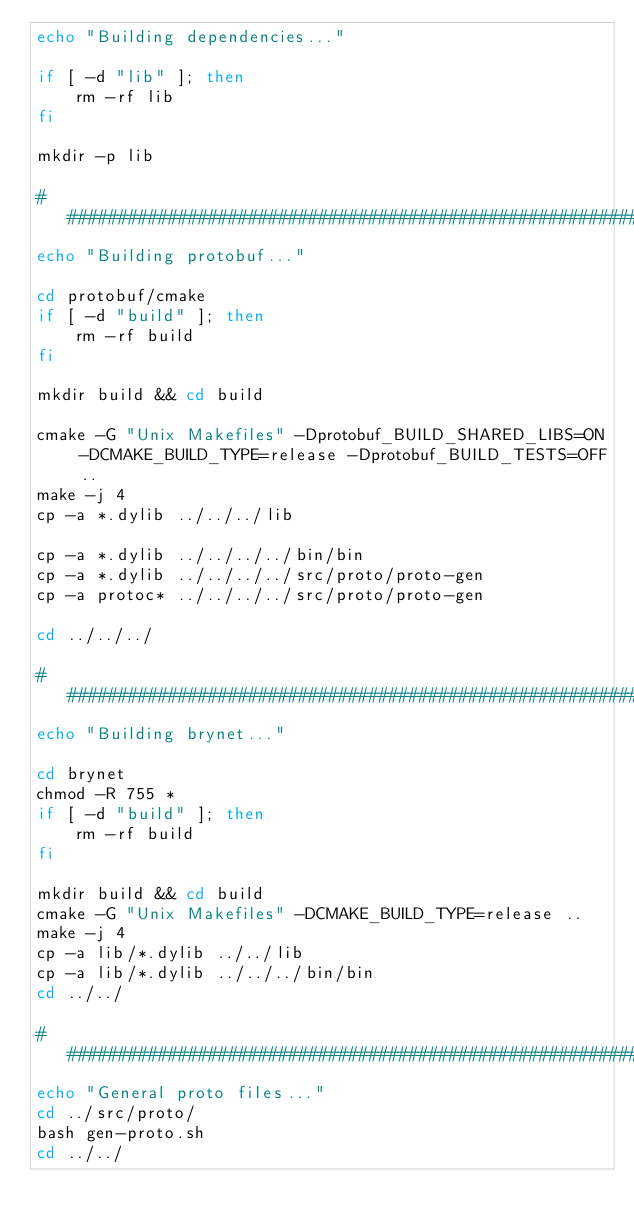Convert code to text. <code><loc_0><loc_0><loc_500><loc_500><_Bash_>echo "Building dependencies..."

if [ -d "lib" ]; then
    rm -rf lib
fi

mkdir -p lib

#####################################################################
echo "Building protobuf..."

cd protobuf/cmake
if [ -d "build" ]; then
    rm -rf build
fi

mkdir build && cd build

cmake -G "Unix Makefiles" -Dprotobuf_BUILD_SHARED_LIBS=ON -DCMAKE_BUILD_TYPE=release -Dprotobuf_BUILD_TESTS=OFF ..
make -j 4
cp -a *.dylib ../../../lib

cp -a *.dylib ../../../../bin/bin
cp -a *.dylib ../../../../src/proto/proto-gen
cp -a protoc* ../../../../src/proto/proto-gen

cd ../../../

##################################################################
echo "Building brynet..."

cd brynet
chmod -R 755 *
if [ -d "build" ]; then
    rm -rf build
fi

mkdir build && cd build
cmake -G "Unix Makefiles" -DCMAKE_BUILD_TYPE=release ..
make -j 4
cp -a lib/*.dylib ../../lib
cp -a lib/*.dylib ../../../bin/bin
cd ../../

##################################################################
echo "General proto files..."
cd ../src/proto/
bash gen-proto.sh
cd ../../
</code> 